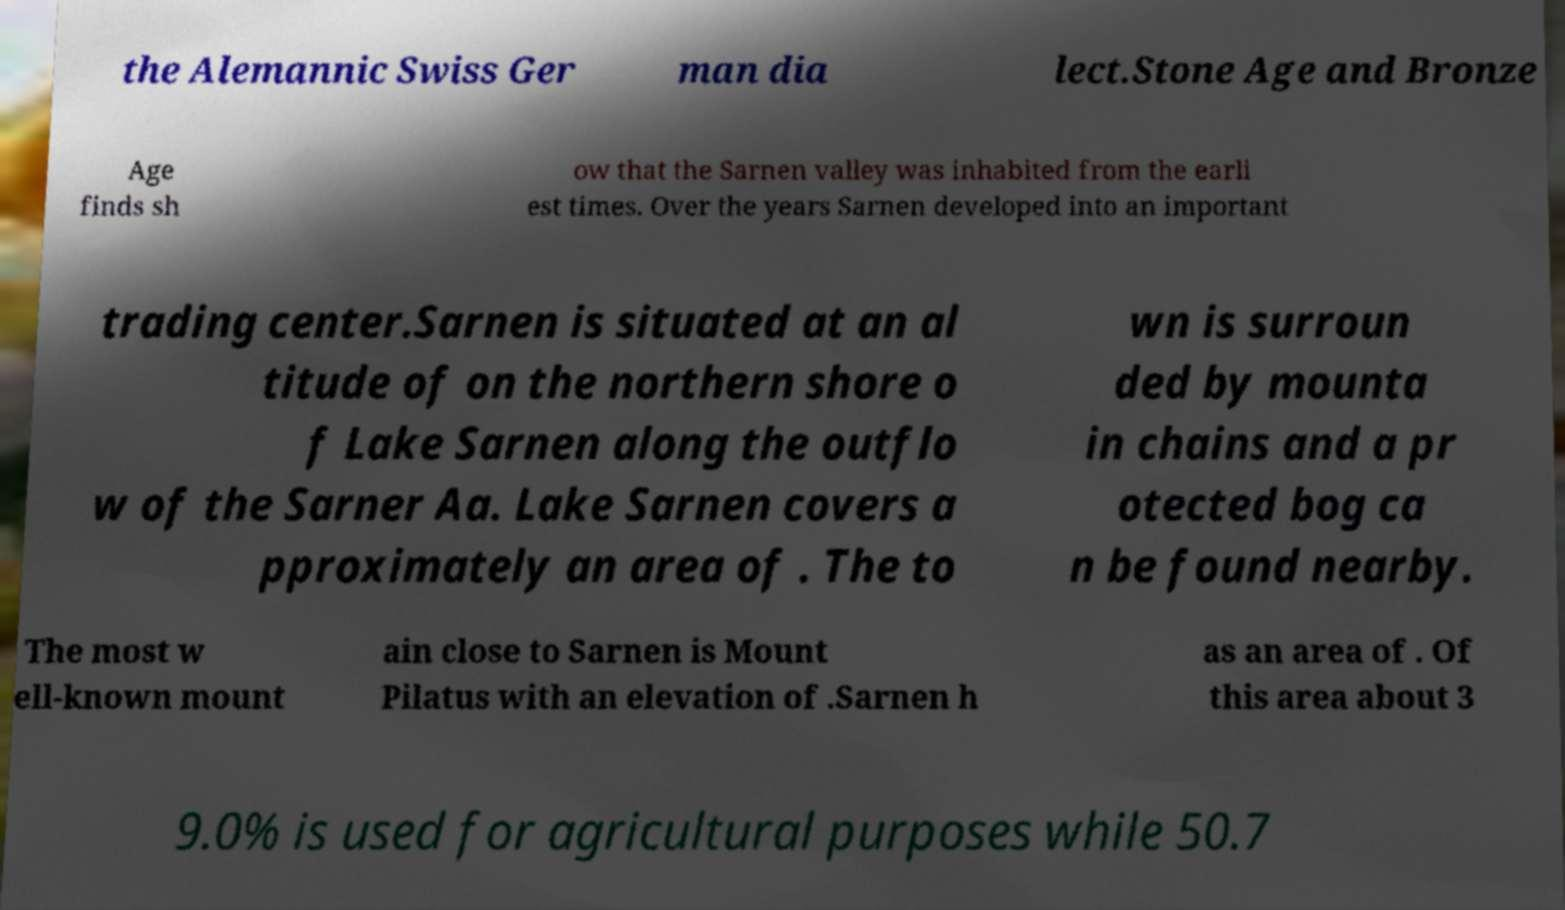Please identify and transcribe the text found in this image. the Alemannic Swiss Ger man dia lect.Stone Age and Bronze Age finds sh ow that the Sarnen valley was inhabited from the earli est times. Over the years Sarnen developed into an important trading center.Sarnen is situated at an al titude of on the northern shore o f Lake Sarnen along the outflo w of the Sarner Aa. Lake Sarnen covers a pproximately an area of . The to wn is surroun ded by mounta in chains and a pr otected bog ca n be found nearby. The most w ell-known mount ain close to Sarnen is Mount Pilatus with an elevation of .Sarnen h as an area of . Of this area about 3 9.0% is used for agricultural purposes while 50.7 